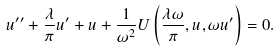<formula> <loc_0><loc_0><loc_500><loc_500>u ^ { \prime \prime } + \frac { \lambda } { \pi } u ^ { \prime } + u + \frac { 1 } { \omega ^ { 2 } } U \left ( \frac { \lambda \omega } { \pi } , u , \omega u ^ { \prime } \right ) = 0 .</formula> 